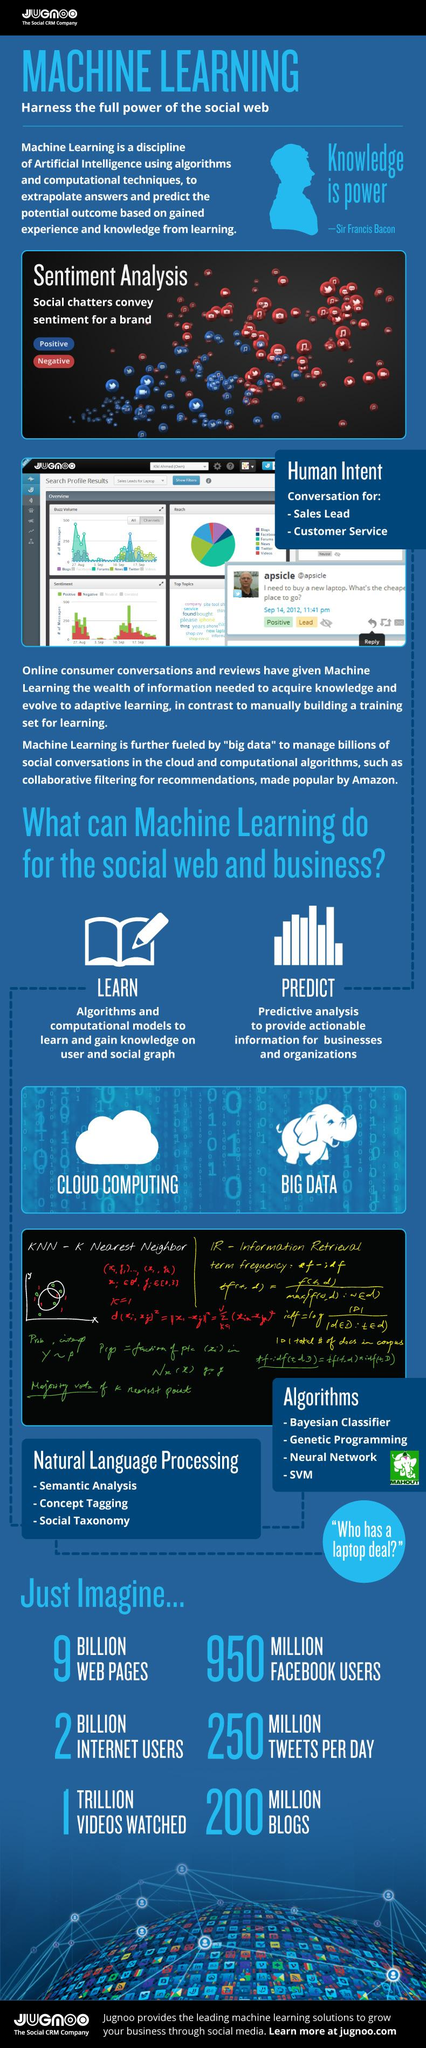Highlight a few significant elements in this photo. There are four algorithms listed. There are three types of Natural Language Processing listed. The highest value of positive sentiments was reached on Day 17, in September. The animal that is depicted near the text "Big data" is an elephant. 